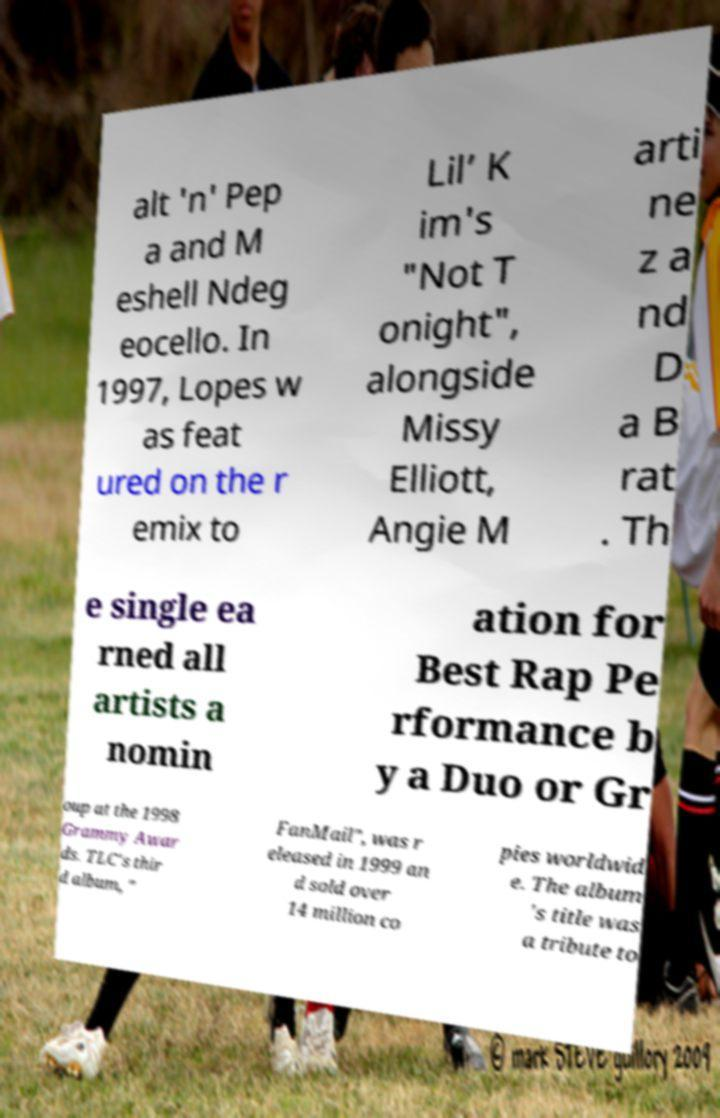Please read and relay the text visible in this image. What does it say? alt 'n' Pep a and M eshell Ndeg eocello. In 1997, Lopes w as feat ured on the r emix to Lil’ K im's "Not T onight", alongside Missy Elliott, Angie M arti ne z a nd D a B rat . Th e single ea rned all artists a nomin ation for Best Rap Pe rformance b y a Duo or Gr oup at the 1998 Grammy Awar ds. TLC's thir d album, " FanMail", was r eleased in 1999 an d sold over 14 million co pies worldwid e. The album 's title was a tribute to 